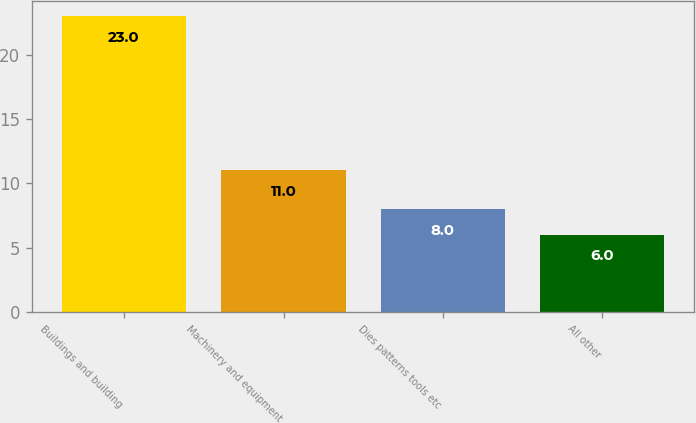Convert chart. <chart><loc_0><loc_0><loc_500><loc_500><bar_chart><fcel>Buildings and building<fcel>Machinery and equipment<fcel>Dies patterns tools etc<fcel>All other<nl><fcel>23<fcel>11<fcel>8<fcel>6<nl></chart> 